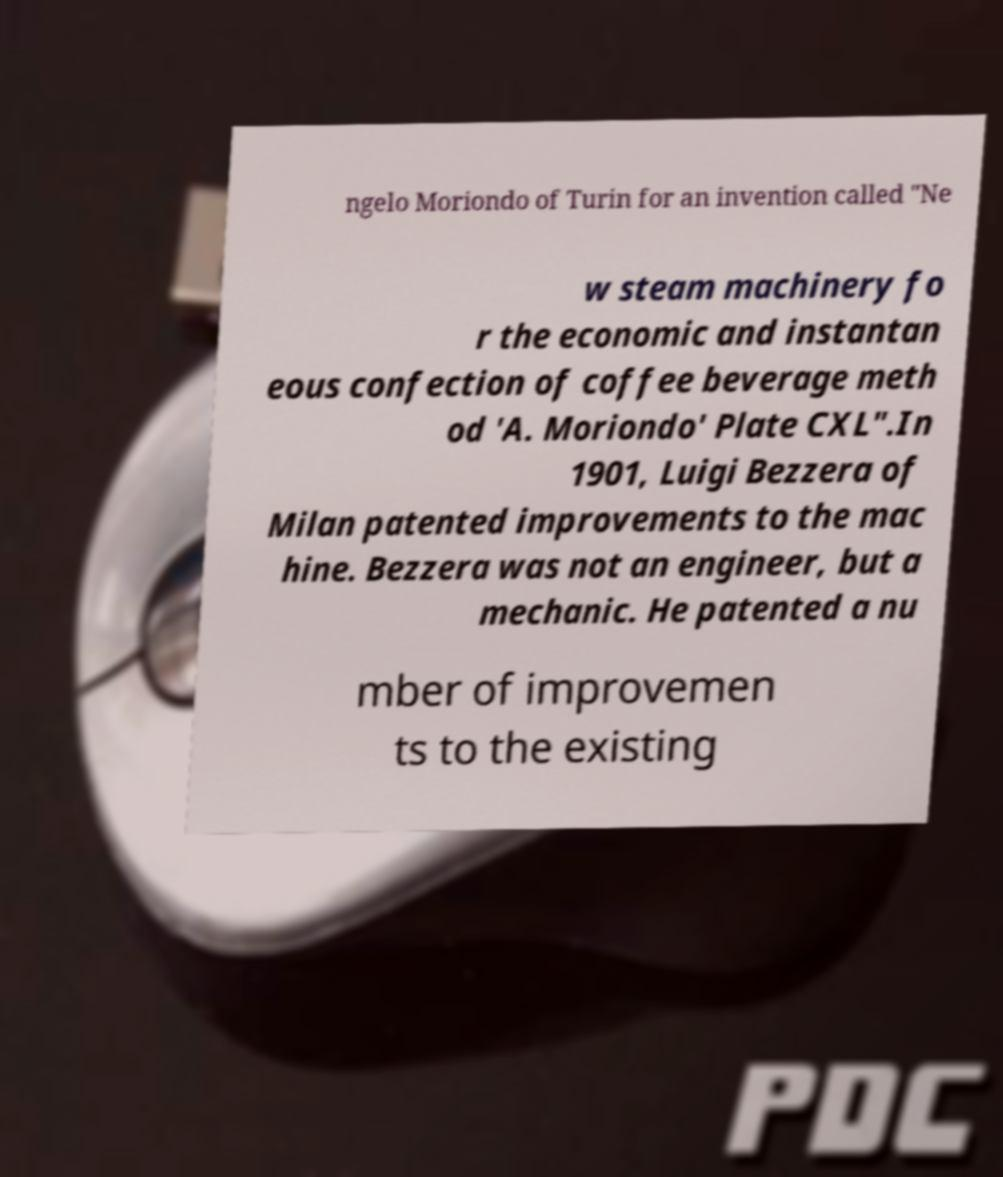What messages or text are displayed in this image? I need them in a readable, typed format. ngelo Moriondo of Turin for an invention called "Ne w steam machinery fo r the economic and instantan eous confection of coffee beverage meth od 'A. Moriondo' Plate CXL".In 1901, Luigi Bezzera of Milan patented improvements to the mac hine. Bezzera was not an engineer, but a mechanic. He patented a nu mber of improvemen ts to the existing 